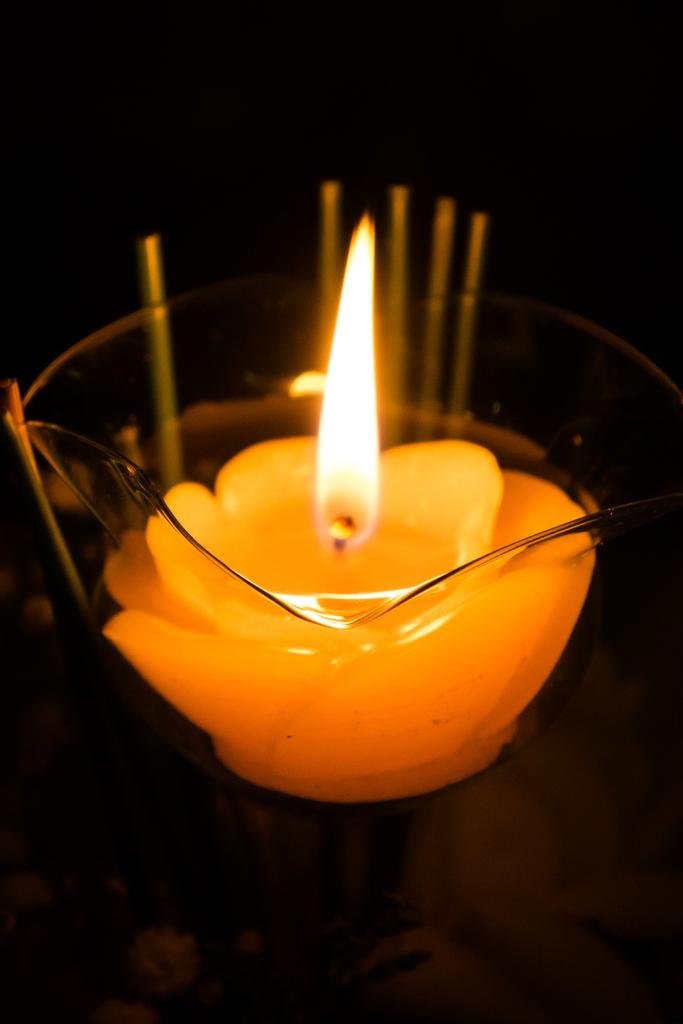What type of container is present in the image? There is a glass bowl in the image. What is inside the glass bowl? There is a candle in the glass bowl. What colors can be seen on the candle? The candle has yellow and orange colors. What is the color of the background in the image? The background of the image is black. How far can the ink be seen running in the image? There is no ink present in the image, so it cannot be seen running. 